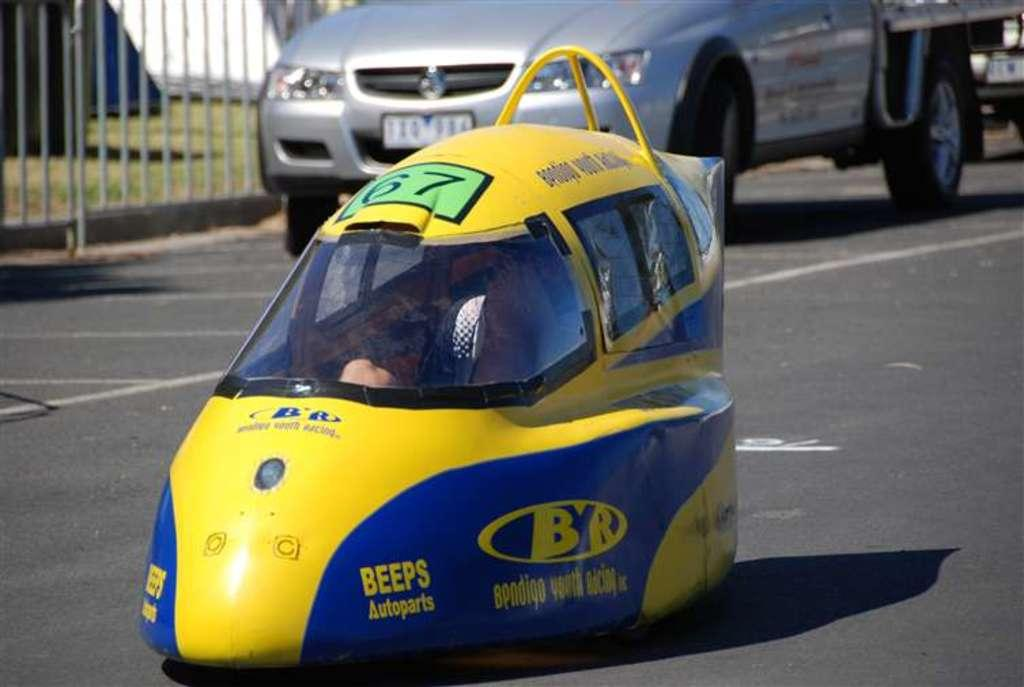What is the main subject of the image? There is a car in the image. What color is the car? The car is yellow. Where is the car located in the image? The car is traveling on a road. What type of vegetation can be seen in the image? There is grass visible in the image. How deep is the hole in the car's engine in the image? There is no hole in the car's engine visible in the image. What type of rod is being used to steer the car in the image? The image does not show any rods being used to steer the car; it only shows the car traveling on a road. 